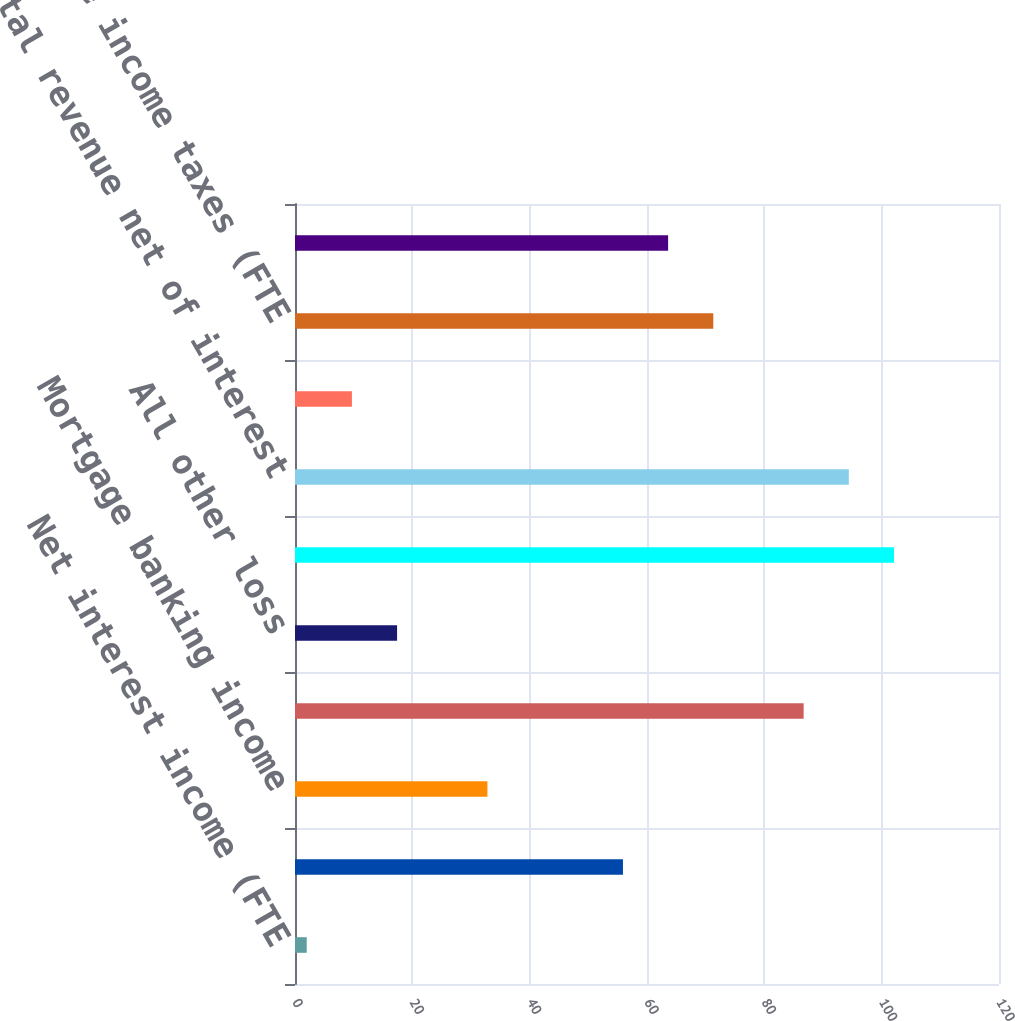<chart> <loc_0><loc_0><loc_500><loc_500><bar_chart><fcel>Net interest income (FTE<fcel>Card income<fcel>Mortgage banking income<fcel>Gains on sales of debt<fcel>All other loss<fcel>Total noninterest income<fcel>Total revenue net of interest<fcel>Noninterest expense<fcel>Loss before income taxes (FTE<fcel>Income tax benefit (FTE basis)<nl><fcel>2<fcel>55.9<fcel>32.8<fcel>86.7<fcel>17.4<fcel>102.1<fcel>94.4<fcel>9.7<fcel>71.3<fcel>63.6<nl></chart> 